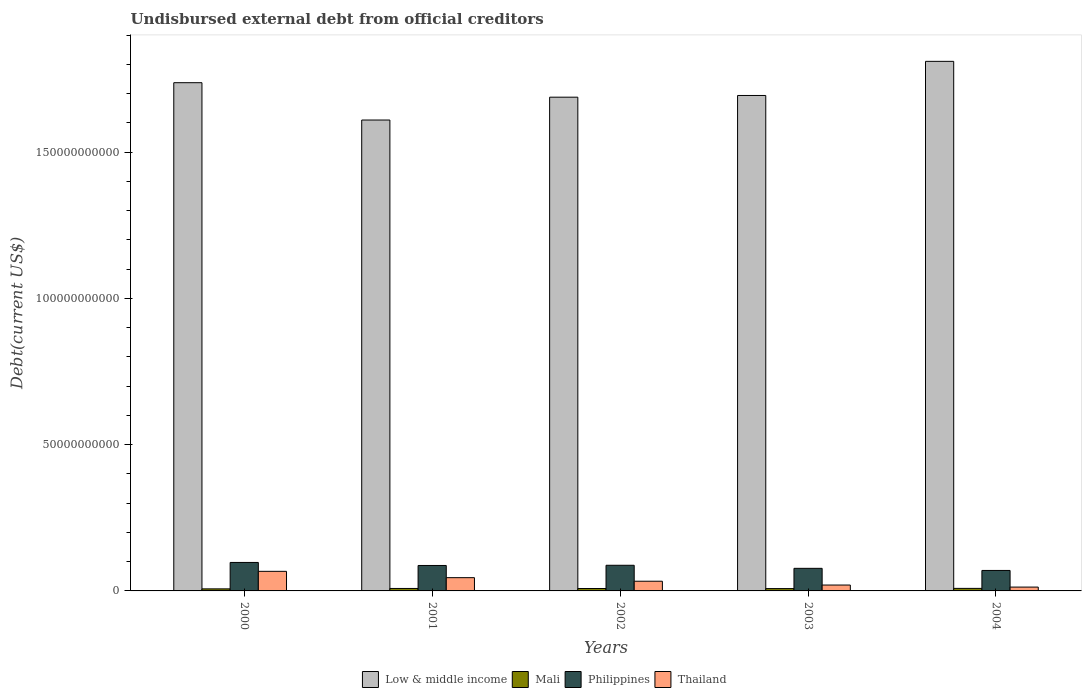How many different coloured bars are there?
Give a very brief answer. 4. How many bars are there on the 1st tick from the left?
Your answer should be compact. 4. How many bars are there on the 2nd tick from the right?
Offer a terse response. 4. What is the label of the 2nd group of bars from the left?
Keep it short and to the point. 2001. What is the total debt in Mali in 2000?
Keep it short and to the point. 7.02e+08. Across all years, what is the maximum total debt in Mali?
Keep it short and to the point. 8.70e+08. Across all years, what is the minimum total debt in Low & middle income?
Keep it short and to the point. 1.61e+11. In which year was the total debt in Thailand maximum?
Give a very brief answer. 2000. What is the total total debt in Mali in the graph?
Offer a very short reply. 4.03e+09. What is the difference between the total debt in Philippines in 2000 and that in 2002?
Ensure brevity in your answer.  9.66e+08. What is the difference between the total debt in Thailand in 2002 and the total debt in Low & middle income in 2004?
Offer a very short reply. -1.78e+11. What is the average total debt in Low & middle income per year?
Keep it short and to the point. 1.71e+11. In the year 2000, what is the difference between the total debt in Mali and total debt in Thailand?
Provide a succinct answer. -6.00e+09. What is the ratio of the total debt in Low & middle income in 2001 to that in 2003?
Provide a short and direct response. 0.95. What is the difference between the highest and the second highest total debt in Low & middle income?
Your answer should be very brief. 7.29e+09. What is the difference between the highest and the lowest total debt in Mali?
Offer a terse response. 1.68e+08. In how many years, is the total debt in Thailand greater than the average total debt in Thailand taken over all years?
Make the answer very short. 2. Is the sum of the total debt in Thailand in 2000 and 2004 greater than the maximum total debt in Low & middle income across all years?
Your answer should be compact. No. Is it the case that in every year, the sum of the total debt in Thailand and total debt in Mali is greater than the sum of total debt in Low & middle income and total debt in Philippines?
Keep it short and to the point. No. What does the 1st bar from the right in 2004 represents?
Give a very brief answer. Thailand. Is it the case that in every year, the sum of the total debt in Mali and total debt in Low & middle income is greater than the total debt in Thailand?
Your answer should be very brief. Yes. How many bars are there?
Offer a terse response. 20. How many years are there in the graph?
Your response must be concise. 5. What is the difference between two consecutive major ticks on the Y-axis?
Provide a succinct answer. 5.00e+1. Are the values on the major ticks of Y-axis written in scientific E-notation?
Keep it short and to the point. No. How many legend labels are there?
Provide a succinct answer. 4. What is the title of the graph?
Your response must be concise. Undisbursed external debt from official creditors. Does "Bahrain" appear as one of the legend labels in the graph?
Provide a succinct answer. No. What is the label or title of the Y-axis?
Provide a succinct answer. Debt(current US$). What is the Debt(current US$) of Low & middle income in 2000?
Make the answer very short. 1.74e+11. What is the Debt(current US$) in Mali in 2000?
Your response must be concise. 7.02e+08. What is the Debt(current US$) in Philippines in 2000?
Your response must be concise. 9.73e+09. What is the Debt(current US$) in Thailand in 2000?
Provide a short and direct response. 6.70e+09. What is the Debt(current US$) in Low & middle income in 2001?
Keep it short and to the point. 1.61e+11. What is the Debt(current US$) of Mali in 2001?
Provide a succinct answer. 8.39e+08. What is the Debt(current US$) in Philippines in 2001?
Your answer should be very brief. 8.70e+09. What is the Debt(current US$) of Thailand in 2001?
Your answer should be very brief. 4.53e+09. What is the Debt(current US$) in Low & middle income in 2002?
Make the answer very short. 1.69e+11. What is the Debt(current US$) in Mali in 2002?
Keep it short and to the point. 8.25e+08. What is the Debt(current US$) in Philippines in 2002?
Give a very brief answer. 8.77e+09. What is the Debt(current US$) of Thailand in 2002?
Ensure brevity in your answer.  3.32e+09. What is the Debt(current US$) in Low & middle income in 2003?
Ensure brevity in your answer.  1.69e+11. What is the Debt(current US$) of Mali in 2003?
Give a very brief answer. 7.98e+08. What is the Debt(current US$) in Philippines in 2003?
Offer a very short reply. 7.72e+09. What is the Debt(current US$) in Thailand in 2003?
Provide a succinct answer. 2.01e+09. What is the Debt(current US$) of Low & middle income in 2004?
Offer a very short reply. 1.81e+11. What is the Debt(current US$) of Mali in 2004?
Your answer should be very brief. 8.70e+08. What is the Debt(current US$) in Philippines in 2004?
Make the answer very short. 7.00e+09. What is the Debt(current US$) in Thailand in 2004?
Ensure brevity in your answer.  1.31e+09. Across all years, what is the maximum Debt(current US$) in Low & middle income?
Keep it short and to the point. 1.81e+11. Across all years, what is the maximum Debt(current US$) in Mali?
Offer a very short reply. 8.70e+08. Across all years, what is the maximum Debt(current US$) of Philippines?
Your response must be concise. 9.73e+09. Across all years, what is the maximum Debt(current US$) of Thailand?
Make the answer very short. 6.70e+09. Across all years, what is the minimum Debt(current US$) in Low & middle income?
Provide a short and direct response. 1.61e+11. Across all years, what is the minimum Debt(current US$) in Mali?
Provide a short and direct response. 7.02e+08. Across all years, what is the minimum Debt(current US$) in Philippines?
Provide a short and direct response. 7.00e+09. Across all years, what is the minimum Debt(current US$) in Thailand?
Offer a terse response. 1.31e+09. What is the total Debt(current US$) in Low & middle income in the graph?
Your response must be concise. 8.54e+11. What is the total Debt(current US$) of Mali in the graph?
Your response must be concise. 4.03e+09. What is the total Debt(current US$) in Philippines in the graph?
Your answer should be compact. 4.19e+1. What is the total Debt(current US$) of Thailand in the graph?
Offer a terse response. 1.79e+1. What is the difference between the Debt(current US$) in Low & middle income in 2000 and that in 2001?
Provide a succinct answer. 1.28e+1. What is the difference between the Debt(current US$) in Mali in 2000 and that in 2001?
Provide a short and direct response. -1.38e+08. What is the difference between the Debt(current US$) of Philippines in 2000 and that in 2001?
Make the answer very short. 1.04e+09. What is the difference between the Debt(current US$) of Thailand in 2000 and that in 2001?
Offer a very short reply. 2.17e+09. What is the difference between the Debt(current US$) of Low & middle income in 2000 and that in 2002?
Ensure brevity in your answer.  4.95e+09. What is the difference between the Debt(current US$) in Mali in 2000 and that in 2002?
Give a very brief answer. -1.23e+08. What is the difference between the Debt(current US$) of Philippines in 2000 and that in 2002?
Make the answer very short. 9.66e+08. What is the difference between the Debt(current US$) in Thailand in 2000 and that in 2002?
Give a very brief answer. 3.38e+09. What is the difference between the Debt(current US$) in Low & middle income in 2000 and that in 2003?
Offer a very short reply. 4.37e+09. What is the difference between the Debt(current US$) in Mali in 2000 and that in 2003?
Ensure brevity in your answer.  -9.66e+07. What is the difference between the Debt(current US$) in Philippines in 2000 and that in 2003?
Provide a succinct answer. 2.01e+09. What is the difference between the Debt(current US$) in Thailand in 2000 and that in 2003?
Offer a terse response. 4.69e+09. What is the difference between the Debt(current US$) in Low & middle income in 2000 and that in 2004?
Your answer should be very brief. -7.29e+09. What is the difference between the Debt(current US$) of Mali in 2000 and that in 2004?
Offer a terse response. -1.68e+08. What is the difference between the Debt(current US$) of Philippines in 2000 and that in 2004?
Provide a short and direct response. 2.73e+09. What is the difference between the Debt(current US$) of Thailand in 2000 and that in 2004?
Your answer should be compact. 5.39e+09. What is the difference between the Debt(current US$) of Low & middle income in 2001 and that in 2002?
Make the answer very short. -7.81e+09. What is the difference between the Debt(current US$) of Mali in 2001 and that in 2002?
Provide a short and direct response. 1.43e+07. What is the difference between the Debt(current US$) of Philippines in 2001 and that in 2002?
Make the answer very short. -7.06e+07. What is the difference between the Debt(current US$) in Thailand in 2001 and that in 2002?
Offer a terse response. 1.21e+09. What is the difference between the Debt(current US$) in Low & middle income in 2001 and that in 2003?
Your answer should be compact. -8.39e+09. What is the difference between the Debt(current US$) of Mali in 2001 and that in 2003?
Offer a terse response. 4.10e+07. What is the difference between the Debt(current US$) in Philippines in 2001 and that in 2003?
Keep it short and to the point. 9.76e+08. What is the difference between the Debt(current US$) of Thailand in 2001 and that in 2003?
Ensure brevity in your answer.  2.52e+09. What is the difference between the Debt(current US$) of Low & middle income in 2001 and that in 2004?
Your answer should be very brief. -2.01e+1. What is the difference between the Debt(current US$) in Mali in 2001 and that in 2004?
Your answer should be compact. -3.03e+07. What is the difference between the Debt(current US$) in Philippines in 2001 and that in 2004?
Your answer should be very brief. 1.69e+09. What is the difference between the Debt(current US$) in Thailand in 2001 and that in 2004?
Give a very brief answer. 3.22e+09. What is the difference between the Debt(current US$) of Low & middle income in 2002 and that in 2003?
Offer a very short reply. -5.78e+08. What is the difference between the Debt(current US$) in Mali in 2002 and that in 2003?
Make the answer very short. 2.66e+07. What is the difference between the Debt(current US$) in Philippines in 2002 and that in 2003?
Your answer should be compact. 1.05e+09. What is the difference between the Debt(current US$) of Thailand in 2002 and that in 2003?
Offer a terse response. 1.31e+09. What is the difference between the Debt(current US$) of Low & middle income in 2002 and that in 2004?
Offer a terse response. -1.22e+1. What is the difference between the Debt(current US$) in Mali in 2002 and that in 2004?
Ensure brevity in your answer.  -4.47e+07. What is the difference between the Debt(current US$) of Philippines in 2002 and that in 2004?
Offer a terse response. 1.77e+09. What is the difference between the Debt(current US$) of Thailand in 2002 and that in 2004?
Your answer should be compact. 2.00e+09. What is the difference between the Debt(current US$) in Low & middle income in 2003 and that in 2004?
Give a very brief answer. -1.17e+1. What is the difference between the Debt(current US$) in Mali in 2003 and that in 2004?
Make the answer very short. -7.13e+07. What is the difference between the Debt(current US$) in Philippines in 2003 and that in 2004?
Your response must be concise. 7.19e+08. What is the difference between the Debt(current US$) of Thailand in 2003 and that in 2004?
Your answer should be compact. 6.98e+08. What is the difference between the Debt(current US$) of Low & middle income in 2000 and the Debt(current US$) of Mali in 2001?
Offer a very short reply. 1.73e+11. What is the difference between the Debt(current US$) in Low & middle income in 2000 and the Debt(current US$) in Philippines in 2001?
Make the answer very short. 1.65e+11. What is the difference between the Debt(current US$) in Low & middle income in 2000 and the Debt(current US$) in Thailand in 2001?
Keep it short and to the point. 1.69e+11. What is the difference between the Debt(current US$) in Mali in 2000 and the Debt(current US$) in Philippines in 2001?
Give a very brief answer. -7.99e+09. What is the difference between the Debt(current US$) of Mali in 2000 and the Debt(current US$) of Thailand in 2001?
Give a very brief answer. -3.83e+09. What is the difference between the Debt(current US$) in Philippines in 2000 and the Debt(current US$) in Thailand in 2001?
Provide a short and direct response. 5.20e+09. What is the difference between the Debt(current US$) of Low & middle income in 2000 and the Debt(current US$) of Mali in 2002?
Offer a very short reply. 1.73e+11. What is the difference between the Debt(current US$) in Low & middle income in 2000 and the Debt(current US$) in Philippines in 2002?
Make the answer very short. 1.65e+11. What is the difference between the Debt(current US$) of Low & middle income in 2000 and the Debt(current US$) of Thailand in 2002?
Offer a terse response. 1.70e+11. What is the difference between the Debt(current US$) in Mali in 2000 and the Debt(current US$) in Philippines in 2002?
Provide a short and direct response. -8.06e+09. What is the difference between the Debt(current US$) in Mali in 2000 and the Debt(current US$) in Thailand in 2002?
Your answer should be compact. -2.61e+09. What is the difference between the Debt(current US$) in Philippines in 2000 and the Debt(current US$) in Thailand in 2002?
Provide a short and direct response. 6.42e+09. What is the difference between the Debt(current US$) in Low & middle income in 2000 and the Debt(current US$) in Mali in 2003?
Your answer should be compact. 1.73e+11. What is the difference between the Debt(current US$) of Low & middle income in 2000 and the Debt(current US$) of Philippines in 2003?
Give a very brief answer. 1.66e+11. What is the difference between the Debt(current US$) of Low & middle income in 2000 and the Debt(current US$) of Thailand in 2003?
Make the answer very short. 1.72e+11. What is the difference between the Debt(current US$) of Mali in 2000 and the Debt(current US$) of Philippines in 2003?
Offer a very short reply. -7.02e+09. What is the difference between the Debt(current US$) of Mali in 2000 and the Debt(current US$) of Thailand in 2003?
Ensure brevity in your answer.  -1.31e+09. What is the difference between the Debt(current US$) in Philippines in 2000 and the Debt(current US$) in Thailand in 2003?
Your answer should be compact. 7.72e+09. What is the difference between the Debt(current US$) of Low & middle income in 2000 and the Debt(current US$) of Mali in 2004?
Offer a terse response. 1.73e+11. What is the difference between the Debt(current US$) in Low & middle income in 2000 and the Debt(current US$) in Philippines in 2004?
Offer a terse response. 1.67e+11. What is the difference between the Debt(current US$) in Low & middle income in 2000 and the Debt(current US$) in Thailand in 2004?
Make the answer very short. 1.72e+11. What is the difference between the Debt(current US$) in Mali in 2000 and the Debt(current US$) in Philippines in 2004?
Your answer should be very brief. -6.30e+09. What is the difference between the Debt(current US$) of Mali in 2000 and the Debt(current US$) of Thailand in 2004?
Provide a succinct answer. -6.10e+08. What is the difference between the Debt(current US$) in Philippines in 2000 and the Debt(current US$) in Thailand in 2004?
Give a very brief answer. 8.42e+09. What is the difference between the Debt(current US$) of Low & middle income in 2001 and the Debt(current US$) of Mali in 2002?
Ensure brevity in your answer.  1.60e+11. What is the difference between the Debt(current US$) of Low & middle income in 2001 and the Debt(current US$) of Philippines in 2002?
Your response must be concise. 1.52e+11. What is the difference between the Debt(current US$) of Low & middle income in 2001 and the Debt(current US$) of Thailand in 2002?
Keep it short and to the point. 1.58e+11. What is the difference between the Debt(current US$) of Mali in 2001 and the Debt(current US$) of Philippines in 2002?
Make the answer very short. -7.93e+09. What is the difference between the Debt(current US$) in Mali in 2001 and the Debt(current US$) in Thailand in 2002?
Your answer should be compact. -2.48e+09. What is the difference between the Debt(current US$) of Philippines in 2001 and the Debt(current US$) of Thailand in 2002?
Offer a very short reply. 5.38e+09. What is the difference between the Debt(current US$) of Low & middle income in 2001 and the Debt(current US$) of Mali in 2003?
Make the answer very short. 1.60e+11. What is the difference between the Debt(current US$) of Low & middle income in 2001 and the Debt(current US$) of Philippines in 2003?
Keep it short and to the point. 1.53e+11. What is the difference between the Debt(current US$) in Low & middle income in 2001 and the Debt(current US$) in Thailand in 2003?
Provide a succinct answer. 1.59e+11. What is the difference between the Debt(current US$) in Mali in 2001 and the Debt(current US$) in Philippines in 2003?
Provide a short and direct response. -6.88e+09. What is the difference between the Debt(current US$) of Mali in 2001 and the Debt(current US$) of Thailand in 2003?
Offer a terse response. -1.17e+09. What is the difference between the Debt(current US$) in Philippines in 2001 and the Debt(current US$) in Thailand in 2003?
Ensure brevity in your answer.  6.69e+09. What is the difference between the Debt(current US$) in Low & middle income in 2001 and the Debt(current US$) in Mali in 2004?
Keep it short and to the point. 1.60e+11. What is the difference between the Debt(current US$) of Low & middle income in 2001 and the Debt(current US$) of Philippines in 2004?
Provide a succinct answer. 1.54e+11. What is the difference between the Debt(current US$) of Low & middle income in 2001 and the Debt(current US$) of Thailand in 2004?
Your answer should be compact. 1.60e+11. What is the difference between the Debt(current US$) in Mali in 2001 and the Debt(current US$) in Philippines in 2004?
Your response must be concise. -6.16e+09. What is the difference between the Debt(current US$) in Mali in 2001 and the Debt(current US$) in Thailand in 2004?
Ensure brevity in your answer.  -4.73e+08. What is the difference between the Debt(current US$) of Philippines in 2001 and the Debt(current US$) of Thailand in 2004?
Your answer should be very brief. 7.38e+09. What is the difference between the Debt(current US$) of Low & middle income in 2002 and the Debt(current US$) of Mali in 2003?
Offer a terse response. 1.68e+11. What is the difference between the Debt(current US$) of Low & middle income in 2002 and the Debt(current US$) of Philippines in 2003?
Ensure brevity in your answer.  1.61e+11. What is the difference between the Debt(current US$) of Low & middle income in 2002 and the Debt(current US$) of Thailand in 2003?
Provide a succinct answer. 1.67e+11. What is the difference between the Debt(current US$) of Mali in 2002 and the Debt(current US$) of Philippines in 2003?
Make the answer very short. -6.90e+09. What is the difference between the Debt(current US$) in Mali in 2002 and the Debt(current US$) in Thailand in 2003?
Provide a succinct answer. -1.19e+09. What is the difference between the Debt(current US$) of Philippines in 2002 and the Debt(current US$) of Thailand in 2003?
Offer a terse response. 6.76e+09. What is the difference between the Debt(current US$) of Low & middle income in 2002 and the Debt(current US$) of Mali in 2004?
Provide a short and direct response. 1.68e+11. What is the difference between the Debt(current US$) of Low & middle income in 2002 and the Debt(current US$) of Philippines in 2004?
Ensure brevity in your answer.  1.62e+11. What is the difference between the Debt(current US$) in Low & middle income in 2002 and the Debt(current US$) in Thailand in 2004?
Offer a terse response. 1.67e+11. What is the difference between the Debt(current US$) of Mali in 2002 and the Debt(current US$) of Philippines in 2004?
Provide a short and direct response. -6.18e+09. What is the difference between the Debt(current US$) in Mali in 2002 and the Debt(current US$) in Thailand in 2004?
Provide a succinct answer. -4.87e+08. What is the difference between the Debt(current US$) in Philippines in 2002 and the Debt(current US$) in Thailand in 2004?
Offer a terse response. 7.45e+09. What is the difference between the Debt(current US$) of Low & middle income in 2003 and the Debt(current US$) of Mali in 2004?
Provide a succinct answer. 1.69e+11. What is the difference between the Debt(current US$) of Low & middle income in 2003 and the Debt(current US$) of Philippines in 2004?
Offer a terse response. 1.62e+11. What is the difference between the Debt(current US$) of Low & middle income in 2003 and the Debt(current US$) of Thailand in 2004?
Make the answer very short. 1.68e+11. What is the difference between the Debt(current US$) of Mali in 2003 and the Debt(current US$) of Philippines in 2004?
Offer a terse response. -6.20e+09. What is the difference between the Debt(current US$) of Mali in 2003 and the Debt(current US$) of Thailand in 2004?
Offer a very short reply. -5.14e+08. What is the difference between the Debt(current US$) of Philippines in 2003 and the Debt(current US$) of Thailand in 2004?
Your response must be concise. 6.41e+09. What is the average Debt(current US$) of Low & middle income per year?
Ensure brevity in your answer.  1.71e+11. What is the average Debt(current US$) in Mali per year?
Offer a terse response. 8.07e+08. What is the average Debt(current US$) of Philippines per year?
Keep it short and to the point. 8.38e+09. What is the average Debt(current US$) in Thailand per year?
Make the answer very short. 3.57e+09. In the year 2000, what is the difference between the Debt(current US$) in Low & middle income and Debt(current US$) in Mali?
Keep it short and to the point. 1.73e+11. In the year 2000, what is the difference between the Debt(current US$) of Low & middle income and Debt(current US$) of Philippines?
Provide a succinct answer. 1.64e+11. In the year 2000, what is the difference between the Debt(current US$) of Low & middle income and Debt(current US$) of Thailand?
Ensure brevity in your answer.  1.67e+11. In the year 2000, what is the difference between the Debt(current US$) in Mali and Debt(current US$) in Philippines?
Your answer should be very brief. -9.03e+09. In the year 2000, what is the difference between the Debt(current US$) of Mali and Debt(current US$) of Thailand?
Offer a terse response. -6.00e+09. In the year 2000, what is the difference between the Debt(current US$) in Philippines and Debt(current US$) in Thailand?
Provide a short and direct response. 3.04e+09. In the year 2001, what is the difference between the Debt(current US$) in Low & middle income and Debt(current US$) in Mali?
Provide a short and direct response. 1.60e+11. In the year 2001, what is the difference between the Debt(current US$) of Low & middle income and Debt(current US$) of Philippines?
Keep it short and to the point. 1.52e+11. In the year 2001, what is the difference between the Debt(current US$) in Low & middle income and Debt(current US$) in Thailand?
Provide a succinct answer. 1.56e+11. In the year 2001, what is the difference between the Debt(current US$) of Mali and Debt(current US$) of Philippines?
Keep it short and to the point. -7.86e+09. In the year 2001, what is the difference between the Debt(current US$) of Mali and Debt(current US$) of Thailand?
Make the answer very short. -3.69e+09. In the year 2001, what is the difference between the Debt(current US$) in Philippines and Debt(current US$) in Thailand?
Make the answer very short. 4.17e+09. In the year 2002, what is the difference between the Debt(current US$) of Low & middle income and Debt(current US$) of Mali?
Keep it short and to the point. 1.68e+11. In the year 2002, what is the difference between the Debt(current US$) of Low & middle income and Debt(current US$) of Philippines?
Provide a succinct answer. 1.60e+11. In the year 2002, what is the difference between the Debt(current US$) in Low & middle income and Debt(current US$) in Thailand?
Keep it short and to the point. 1.65e+11. In the year 2002, what is the difference between the Debt(current US$) in Mali and Debt(current US$) in Philippines?
Provide a succinct answer. -7.94e+09. In the year 2002, what is the difference between the Debt(current US$) in Mali and Debt(current US$) in Thailand?
Offer a terse response. -2.49e+09. In the year 2002, what is the difference between the Debt(current US$) of Philippines and Debt(current US$) of Thailand?
Ensure brevity in your answer.  5.45e+09. In the year 2003, what is the difference between the Debt(current US$) of Low & middle income and Debt(current US$) of Mali?
Keep it short and to the point. 1.69e+11. In the year 2003, what is the difference between the Debt(current US$) of Low & middle income and Debt(current US$) of Philippines?
Provide a short and direct response. 1.62e+11. In the year 2003, what is the difference between the Debt(current US$) of Low & middle income and Debt(current US$) of Thailand?
Your response must be concise. 1.67e+11. In the year 2003, what is the difference between the Debt(current US$) in Mali and Debt(current US$) in Philippines?
Provide a succinct answer. -6.92e+09. In the year 2003, what is the difference between the Debt(current US$) in Mali and Debt(current US$) in Thailand?
Make the answer very short. -1.21e+09. In the year 2003, what is the difference between the Debt(current US$) of Philippines and Debt(current US$) of Thailand?
Give a very brief answer. 5.71e+09. In the year 2004, what is the difference between the Debt(current US$) in Low & middle income and Debt(current US$) in Mali?
Provide a succinct answer. 1.80e+11. In the year 2004, what is the difference between the Debt(current US$) of Low & middle income and Debt(current US$) of Philippines?
Your response must be concise. 1.74e+11. In the year 2004, what is the difference between the Debt(current US$) in Low & middle income and Debt(current US$) in Thailand?
Give a very brief answer. 1.80e+11. In the year 2004, what is the difference between the Debt(current US$) of Mali and Debt(current US$) of Philippines?
Offer a very short reply. -6.13e+09. In the year 2004, what is the difference between the Debt(current US$) of Mali and Debt(current US$) of Thailand?
Your response must be concise. -4.42e+08. In the year 2004, what is the difference between the Debt(current US$) of Philippines and Debt(current US$) of Thailand?
Ensure brevity in your answer.  5.69e+09. What is the ratio of the Debt(current US$) in Low & middle income in 2000 to that in 2001?
Give a very brief answer. 1.08. What is the ratio of the Debt(current US$) in Mali in 2000 to that in 2001?
Keep it short and to the point. 0.84. What is the ratio of the Debt(current US$) in Philippines in 2000 to that in 2001?
Your answer should be very brief. 1.12. What is the ratio of the Debt(current US$) in Thailand in 2000 to that in 2001?
Ensure brevity in your answer.  1.48. What is the ratio of the Debt(current US$) of Low & middle income in 2000 to that in 2002?
Keep it short and to the point. 1.03. What is the ratio of the Debt(current US$) in Mali in 2000 to that in 2002?
Your answer should be compact. 0.85. What is the ratio of the Debt(current US$) in Philippines in 2000 to that in 2002?
Offer a terse response. 1.11. What is the ratio of the Debt(current US$) of Thailand in 2000 to that in 2002?
Give a very brief answer. 2.02. What is the ratio of the Debt(current US$) of Low & middle income in 2000 to that in 2003?
Ensure brevity in your answer.  1.03. What is the ratio of the Debt(current US$) in Mali in 2000 to that in 2003?
Provide a succinct answer. 0.88. What is the ratio of the Debt(current US$) of Philippines in 2000 to that in 2003?
Your answer should be compact. 1.26. What is the ratio of the Debt(current US$) in Thailand in 2000 to that in 2003?
Your answer should be very brief. 3.33. What is the ratio of the Debt(current US$) in Low & middle income in 2000 to that in 2004?
Give a very brief answer. 0.96. What is the ratio of the Debt(current US$) in Mali in 2000 to that in 2004?
Make the answer very short. 0.81. What is the ratio of the Debt(current US$) of Philippines in 2000 to that in 2004?
Your answer should be compact. 1.39. What is the ratio of the Debt(current US$) of Thailand in 2000 to that in 2004?
Give a very brief answer. 5.1. What is the ratio of the Debt(current US$) in Low & middle income in 2001 to that in 2002?
Your answer should be compact. 0.95. What is the ratio of the Debt(current US$) in Mali in 2001 to that in 2002?
Give a very brief answer. 1.02. What is the ratio of the Debt(current US$) in Philippines in 2001 to that in 2002?
Your answer should be very brief. 0.99. What is the ratio of the Debt(current US$) in Thailand in 2001 to that in 2002?
Your answer should be very brief. 1.37. What is the ratio of the Debt(current US$) of Low & middle income in 2001 to that in 2003?
Provide a short and direct response. 0.95. What is the ratio of the Debt(current US$) of Mali in 2001 to that in 2003?
Offer a very short reply. 1.05. What is the ratio of the Debt(current US$) in Philippines in 2001 to that in 2003?
Your answer should be very brief. 1.13. What is the ratio of the Debt(current US$) of Thailand in 2001 to that in 2003?
Give a very brief answer. 2.25. What is the ratio of the Debt(current US$) in Low & middle income in 2001 to that in 2004?
Make the answer very short. 0.89. What is the ratio of the Debt(current US$) of Mali in 2001 to that in 2004?
Provide a succinct answer. 0.97. What is the ratio of the Debt(current US$) in Philippines in 2001 to that in 2004?
Provide a short and direct response. 1.24. What is the ratio of the Debt(current US$) in Thailand in 2001 to that in 2004?
Give a very brief answer. 3.45. What is the ratio of the Debt(current US$) of Mali in 2002 to that in 2003?
Your answer should be compact. 1.03. What is the ratio of the Debt(current US$) in Philippines in 2002 to that in 2003?
Your response must be concise. 1.14. What is the ratio of the Debt(current US$) in Thailand in 2002 to that in 2003?
Make the answer very short. 1.65. What is the ratio of the Debt(current US$) in Low & middle income in 2002 to that in 2004?
Provide a short and direct response. 0.93. What is the ratio of the Debt(current US$) in Mali in 2002 to that in 2004?
Your answer should be compact. 0.95. What is the ratio of the Debt(current US$) in Philippines in 2002 to that in 2004?
Keep it short and to the point. 1.25. What is the ratio of the Debt(current US$) in Thailand in 2002 to that in 2004?
Keep it short and to the point. 2.53. What is the ratio of the Debt(current US$) of Low & middle income in 2003 to that in 2004?
Provide a succinct answer. 0.94. What is the ratio of the Debt(current US$) in Mali in 2003 to that in 2004?
Give a very brief answer. 0.92. What is the ratio of the Debt(current US$) of Philippines in 2003 to that in 2004?
Offer a very short reply. 1.1. What is the ratio of the Debt(current US$) in Thailand in 2003 to that in 2004?
Provide a succinct answer. 1.53. What is the difference between the highest and the second highest Debt(current US$) in Low & middle income?
Your response must be concise. 7.29e+09. What is the difference between the highest and the second highest Debt(current US$) in Mali?
Your answer should be compact. 3.03e+07. What is the difference between the highest and the second highest Debt(current US$) of Philippines?
Give a very brief answer. 9.66e+08. What is the difference between the highest and the second highest Debt(current US$) of Thailand?
Your answer should be compact. 2.17e+09. What is the difference between the highest and the lowest Debt(current US$) of Low & middle income?
Offer a very short reply. 2.01e+1. What is the difference between the highest and the lowest Debt(current US$) in Mali?
Provide a short and direct response. 1.68e+08. What is the difference between the highest and the lowest Debt(current US$) in Philippines?
Keep it short and to the point. 2.73e+09. What is the difference between the highest and the lowest Debt(current US$) of Thailand?
Your answer should be very brief. 5.39e+09. 